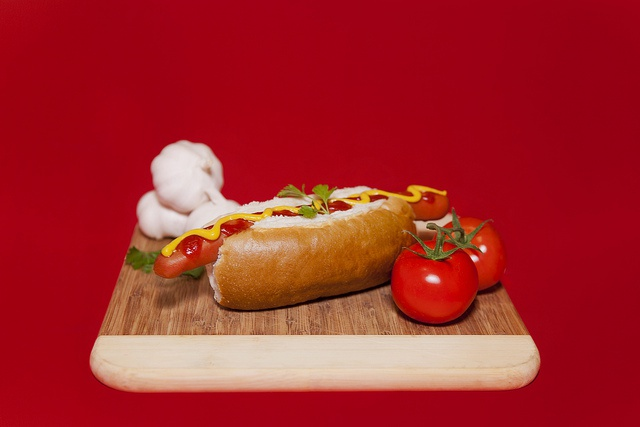Describe the objects in this image and their specific colors. I can see a hot dog in brown, red, maroon, and tan tones in this image. 